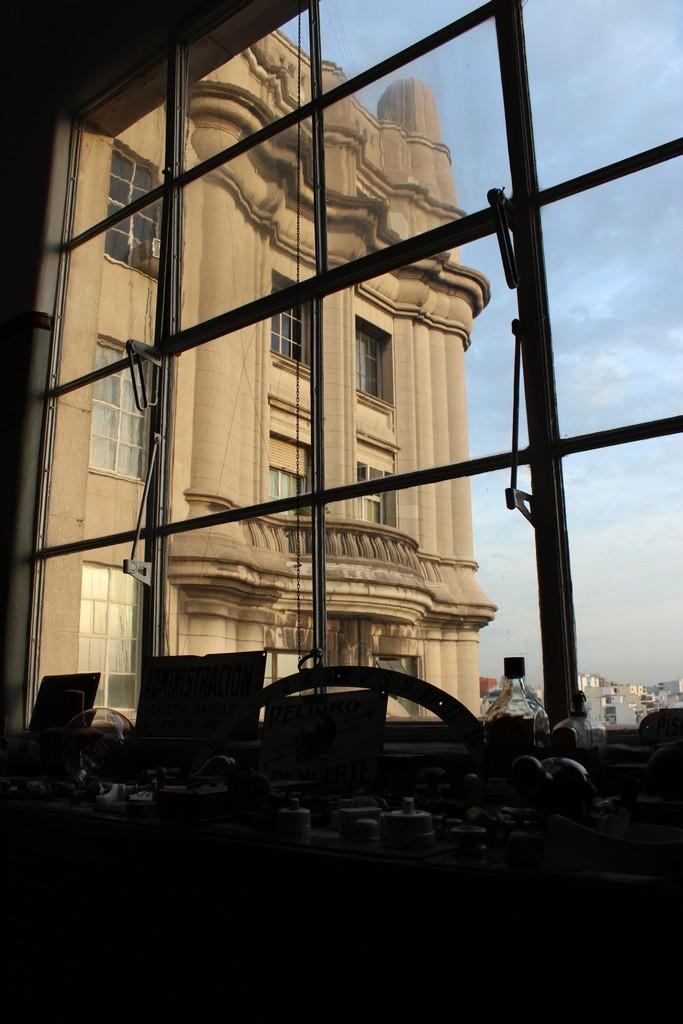What is located on the table in the image? There are items on a table in the image. Where is the table situated? The table is inside a room. What can be seen in the background of the image? There is a window, houses, and the sky visible in the background. What type of hat is hanging on the drawer in the image? There is no hat or drawer present in the image. 